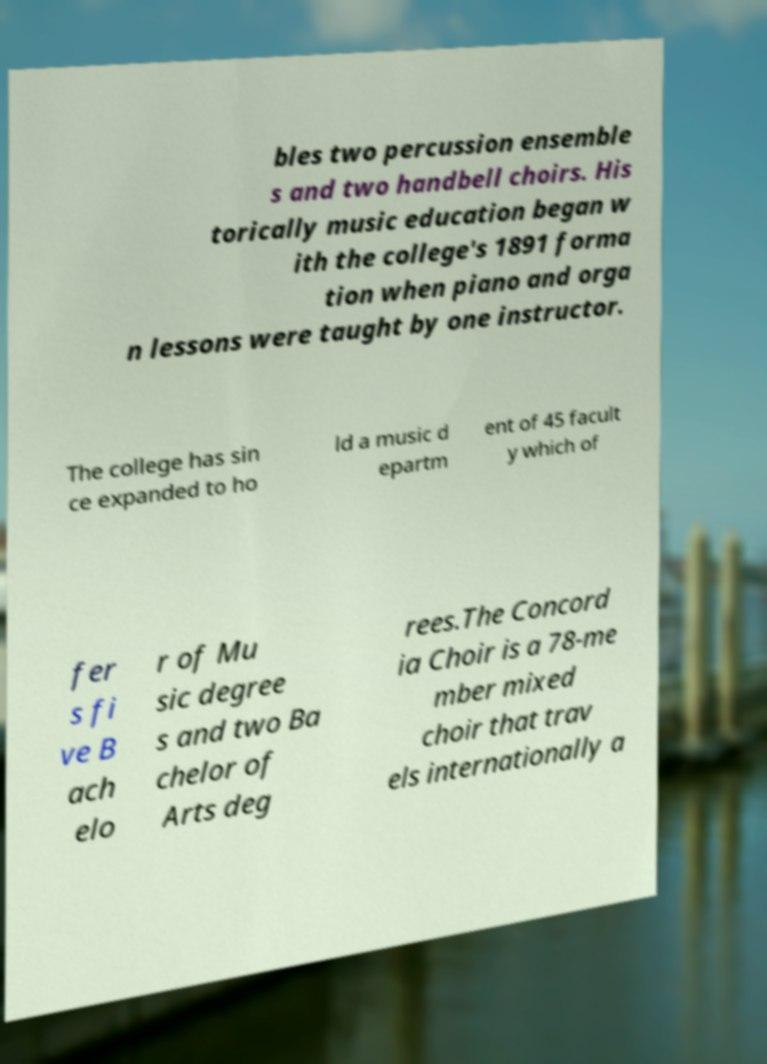Can you accurately transcribe the text from the provided image for me? bles two percussion ensemble s and two handbell choirs. His torically music education began w ith the college's 1891 forma tion when piano and orga n lessons were taught by one instructor. The college has sin ce expanded to ho ld a music d epartm ent of 45 facult y which of fer s fi ve B ach elo r of Mu sic degree s and two Ba chelor of Arts deg rees.The Concord ia Choir is a 78-me mber mixed choir that trav els internationally a 